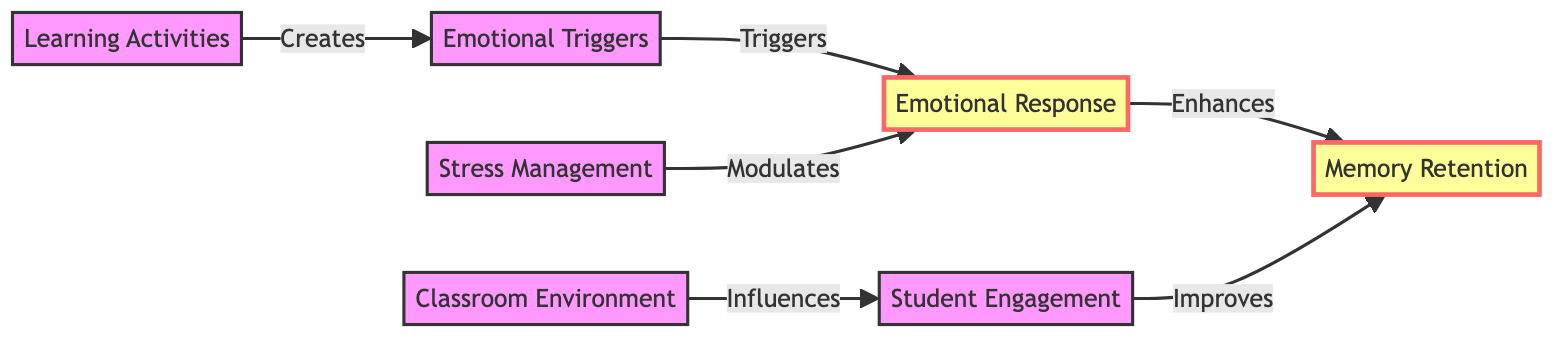What is the primary relationship between Emotional Triggers and Emotional Response? The diagram indicates that Emotional Triggers directly trigger Emotional Response. This is depicted as an arrow pointing from Emotional Triggers to Emotional Response.
Answer: Triggers How many nodes are represented in the diagram? By counting the distinct categories listed in the diagram, we see there are seven nodes: Emotional Triggers, Memory Retention, Emotional Response, Classroom Environment, Student Engagement, Learning Activities, and Stress Management.
Answer: 7 What does Student Engagement influence according to the diagram? The diagram shows a directional arrow leading from Student Engagement to Memory Retention, indicating that Student Engagement improves Memory Retention.
Answer: Memory Retention Which element modulates Emotional Response? Stress Management has a direct relationship illustrated by an arrow pointing to Emotional Response, indicating that it modulates the Emotional Response.
Answer: Stress Management In the diagram, what enhances Memory Retention? The relationship from Emotional Response to Memory Retention suggests that Emotional Response enhances Memory Retention, as indicated by the arrow showing this influence.
Answer: Enhances Which node is influenced by the Classroom Environment? The Classroom Environment influences Student Engagement directly, as indicated by the arrow connecting the two nodes.
Answer: Student Engagement What creates Emotional Triggers? The diagram illustrates that Learning Activities create Emotional Triggers, as indicated by the directional arrow pointing from Learning Activities to Emotional Triggers.
Answer: Creates How many relationships (edges) are present in the diagram? By counting the arrows connecting different nodes, we find there are six edges: Emotional Triggers to Emotional Response, Emotional Response to Memory Retention, Classroom Environment to Student Engagement, Student Engagement to Memory Retention, Learning Activities to Emotional Triggers, and Stress Management to Emotional Response.
Answer: 6 What relationship exists between Emotional Response and Memory Retention? The diagram shows a direct flow from Emotional Response to Memory Retention, demonstrating that Emotional Response enhances Memory Retention as indicated by the arrow.
Answer: Enhances 